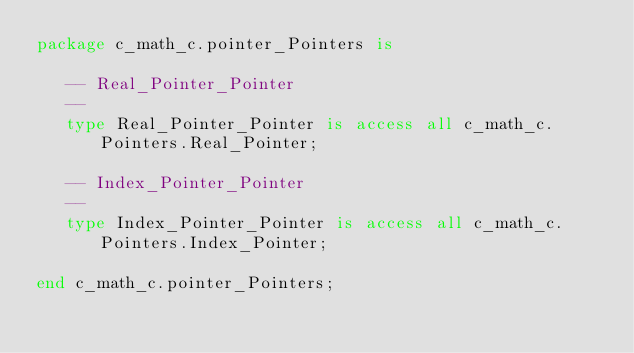Convert code to text. <code><loc_0><loc_0><loc_500><loc_500><_Ada_>package c_math_c.pointer_Pointers is

   -- Real_Pointer_Pointer
   --
   type Real_Pointer_Pointer is access all c_math_c.Pointers.Real_Pointer;

   -- Index_Pointer_Pointer
   --
   type Index_Pointer_Pointer is access all c_math_c.Pointers.Index_Pointer;

end c_math_c.pointer_Pointers;
</code> 